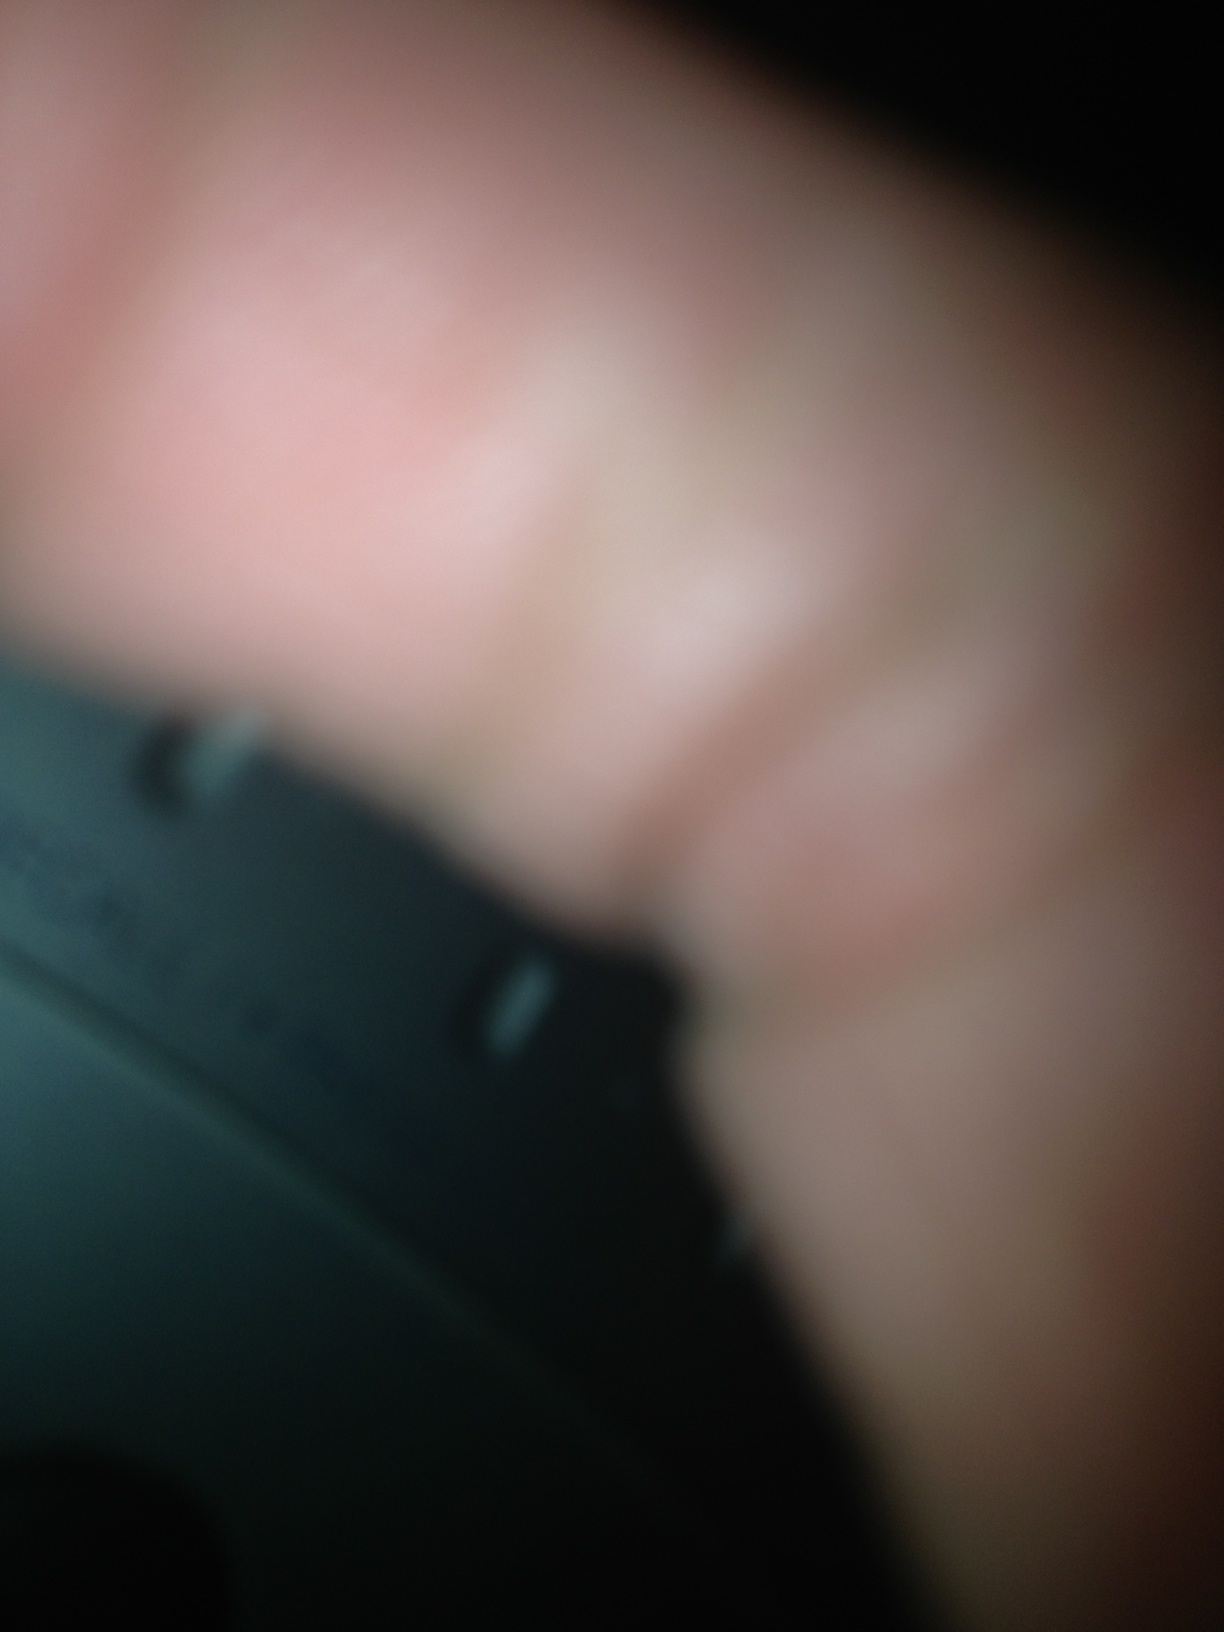What is your best guess about the item in the picture? Given the visible characteristics, my best guess would be that the object could be part of an electronic device, perhaps a jog dial, a large button, or a knob. The blurriness and the finger make it very difficult to be certain. Can this image be something other than a radio? What else could it be? Absolutely, this object could be many things other than a radio. It might be part of a camera lens, a piece of audio equipment, or even a non-electronic object like a dial on a safe or a piece of machinery. Without additional context or a clearer image, the exact nature remains ambiguous. 